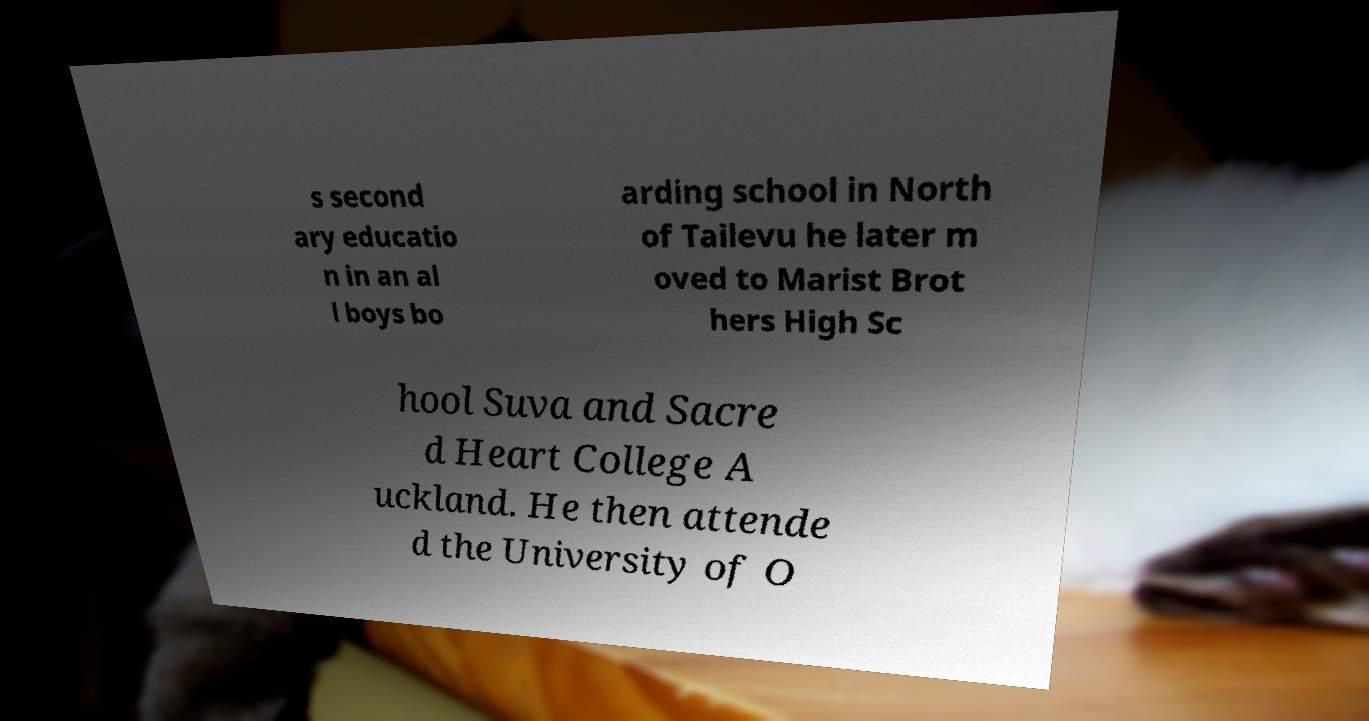There's text embedded in this image that I need extracted. Can you transcribe it verbatim? s second ary educatio n in an al l boys bo arding school in North of Tailevu he later m oved to Marist Brot hers High Sc hool Suva and Sacre d Heart College A uckland. He then attende d the University of O 